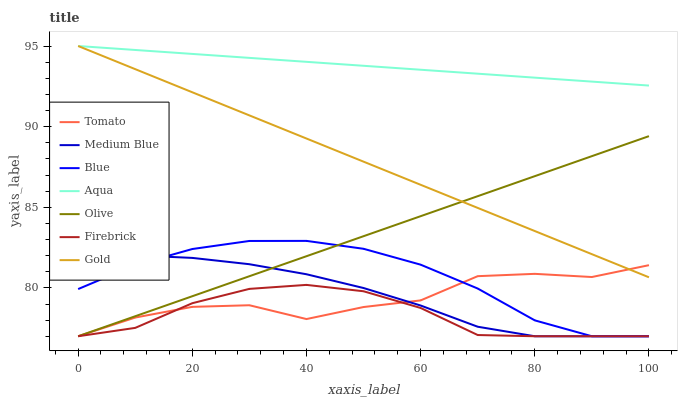Does Firebrick have the minimum area under the curve?
Answer yes or no. Yes. Does Aqua have the maximum area under the curve?
Answer yes or no. Yes. Does Blue have the minimum area under the curve?
Answer yes or no. No. Does Blue have the maximum area under the curve?
Answer yes or no. No. Is Olive the smoothest?
Answer yes or no. Yes. Is Tomato the roughest?
Answer yes or no. Yes. Is Blue the smoothest?
Answer yes or no. No. Is Blue the roughest?
Answer yes or no. No. Does Blue have the lowest value?
Answer yes or no. Yes. Does Gold have the lowest value?
Answer yes or no. No. Does Aqua have the highest value?
Answer yes or no. Yes. Does Blue have the highest value?
Answer yes or no. No. Is Firebrick less than Aqua?
Answer yes or no. Yes. Is Aqua greater than Firebrick?
Answer yes or no. Yes. Does Olive intersect Medium Blue?
Answer yes or no. Yes. Is Olive less than Medium Blue?
Answer yes or no. No. Is Olive greater than Medium Blue?
Answer yes or no. No. Does Firebrick intersect Aqua?
Answer yes or no. No. 